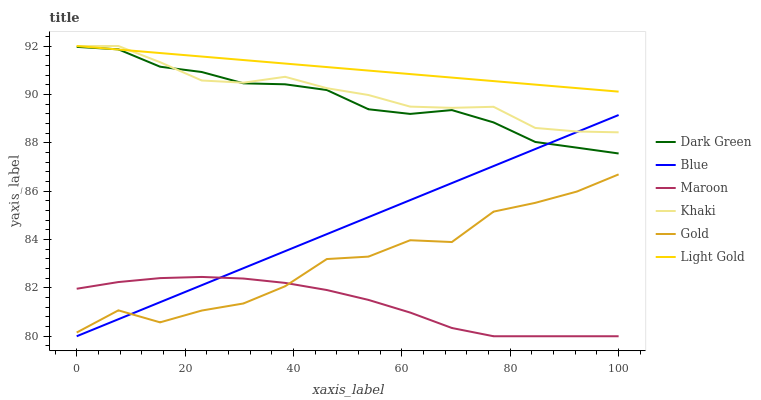Does Maroon have the minimum area under the curve?
Answer yes or no. Yes. Does Light Gold have the maximum area under the curve?
Answer yes or no. Yes. Does Khaki have the minimum area under the curve?
Answer yes or no. No. Does Khaki have the maximum area under the curve?
Answer yes or no. No. Is Blue the smoothest?
Answer yes or no. Yes. Is Gold the roughest?
Answer yes or no. Yes. Is Khaki the smoothest?
Answer yes or no. No. Is Khaki the roughest?
Answer yes or no. No. Does Blue have the lowest value?
Answer yes or no. Yes. Does Khaki have the lowest value?
Answer yes or no. No. Does Light Gold have the highest value?
Answer yes or no. Yes. Does Gold have the highest value?
Answer yes or no. No. Is Gold less than Dark Green?
Answer yes or no. Yes. Is Dark Green greater than Maroon?
Answer yes or no. Yes. Does Blue intersect Khaki?
Answer yes or no. Yes. Is Blue less than Khaki?
Answer yes or no. No. Is Blue greater than Khaki?
Answer yes or no. No. Does Gold intersect Dark Green?
Answer yes or no. No. 